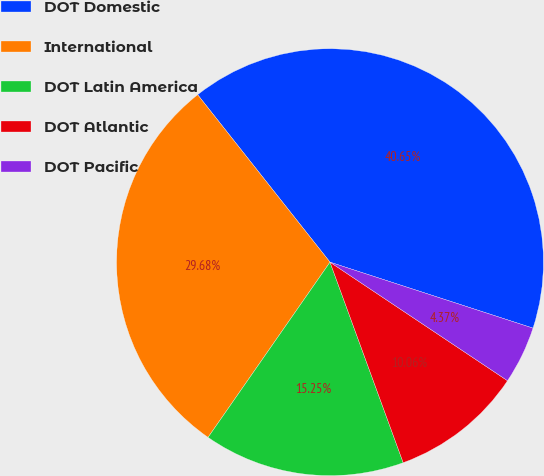<chart> <loc_0><loc_0><loc_500><loc_500><pie_chart><fcel>DOT Domestic<fcel>International<fcel>DOT Latin America<fcel>DOT Atlantic<fcel>DOT Pacific<nl><fcel>40.65%<fcel>29.68%<fcel>15.25%<fcel>10.06%<fcel>4.37%<nl></chart> 